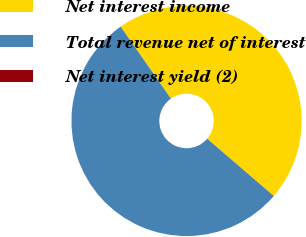Convert chart. <chart><loc_0><loc_0><loc_500><loc_500><pie_chart><fcel>Net interest income<fcel>Total revenue net of interest<fcel>Net interest yield (2)<nl><fcel>46.01%<fcel>53.98%<fcel>0.01%<nl></chart> 